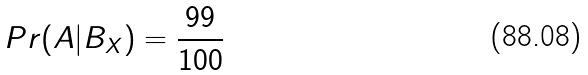<formula> <loc_0><loc_0><loc_500><loc_500>P r ( A | B _ { X } ) = \frac { 9 9 } { 1 0 0 }</formula> 